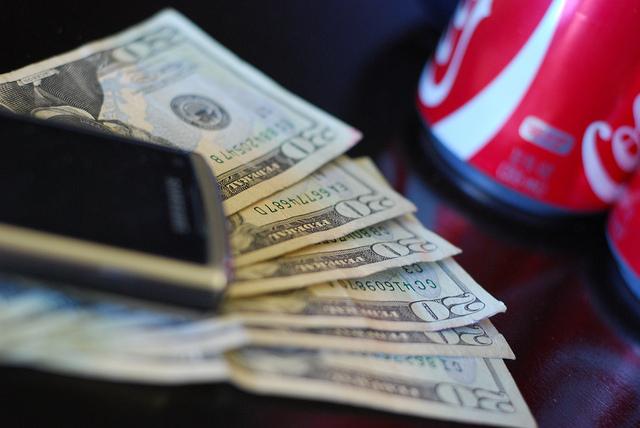What is in front of the phone?
Be succinct. Money. What drink is in the back?
Write a very short answer. Coke. How much money is this?
Give a very brief answer. 120. What is the average of the numbers shown in the image?
Keep it brief. 20. Is that a touch screen phone?
Be succinct. Yes. Do all of the numbers have a four in the tens place?
Give a very brief answer. No. What currency is this?
Quick response, please. Dollar. 